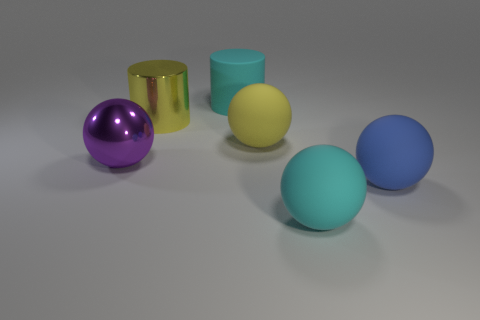Subtract all large cyan spheres. How many spheres are left? 3 Subtract all yellow balls. How many balls are left? 3 Add 2 large matte balls. How many objects exist? 8 Subtract 3 spheres. How many spheres are left? 1 Subtract all small red shiny cylinders. Subtract all large yellow metal objects. How many objects are left? 5 Add 3 big cyan balls. How many big cyan balls are left? 4 Add 6 large yellow cylinders. How many large yellow cylinders exist? 7 Subtract 0 red cylinders. How many objects are left? 6 Subtract all cylinders. How many objects are left? 4 Subtract all purple balls. Subtract all red blocks. How many balls are left? 3 